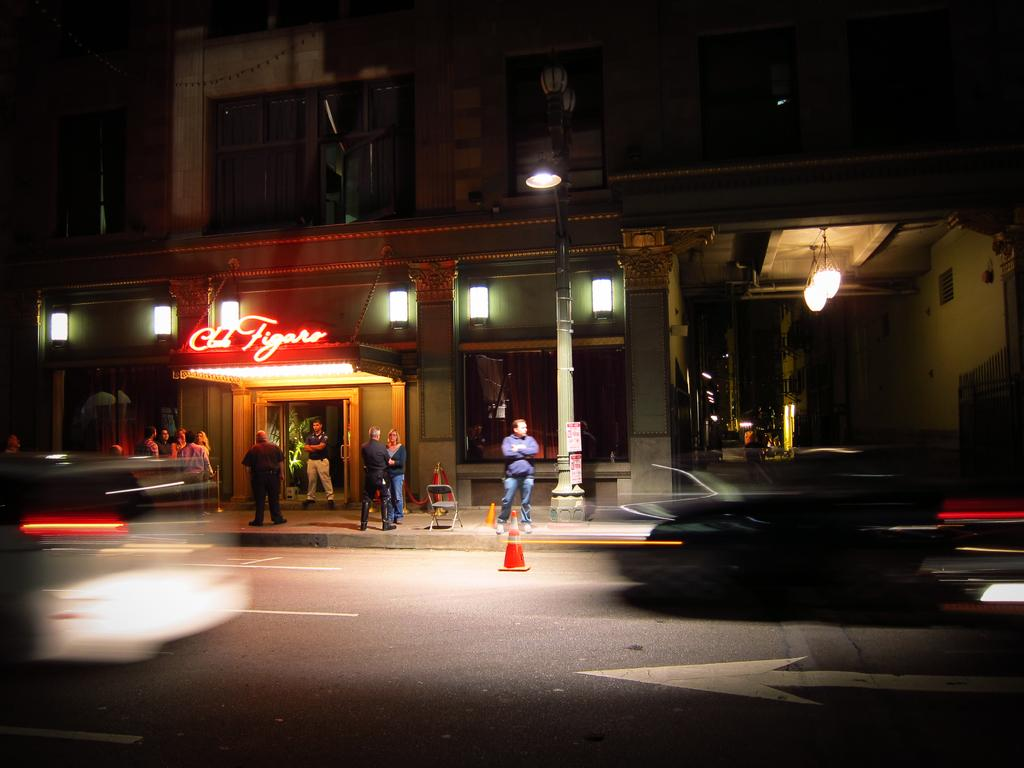What is the main structure in the image? There is a building in the image. Are there any people present in the image? Yes, there are people standing near the building. What else can be seen in the image besides the building and people? There is a pole with a light in the image. Can you hear the cough of the fang in the image? There is no cough or fang present in the image. 